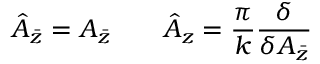<formula> <loc_0><loc_0><loc_500><loc_500>\hat { A } _ { \bar { z } } = A _ { \bar { z } } \quad \hat { A } _ { z } = \frac { \pi } { k } \frac { \delta } { \delta A _ { \bar { z } } }</formula> 